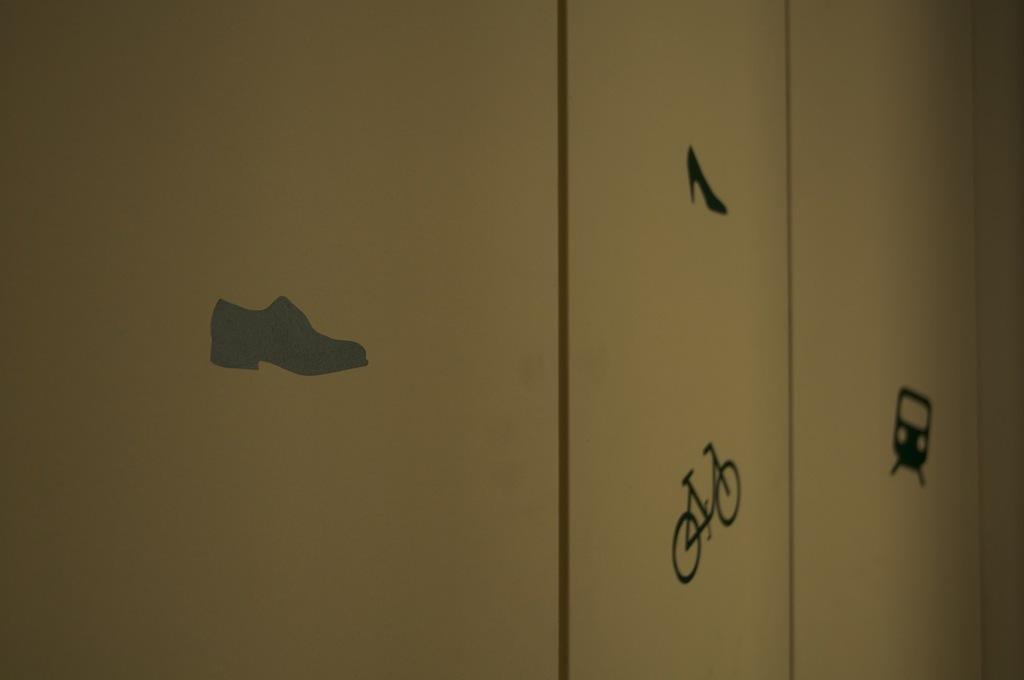In one or two sentences, can you explain what this image depicts? In this picture there is a cupboard in the center of the image, on which there are stickers of a train, bicycle and a shoe. 